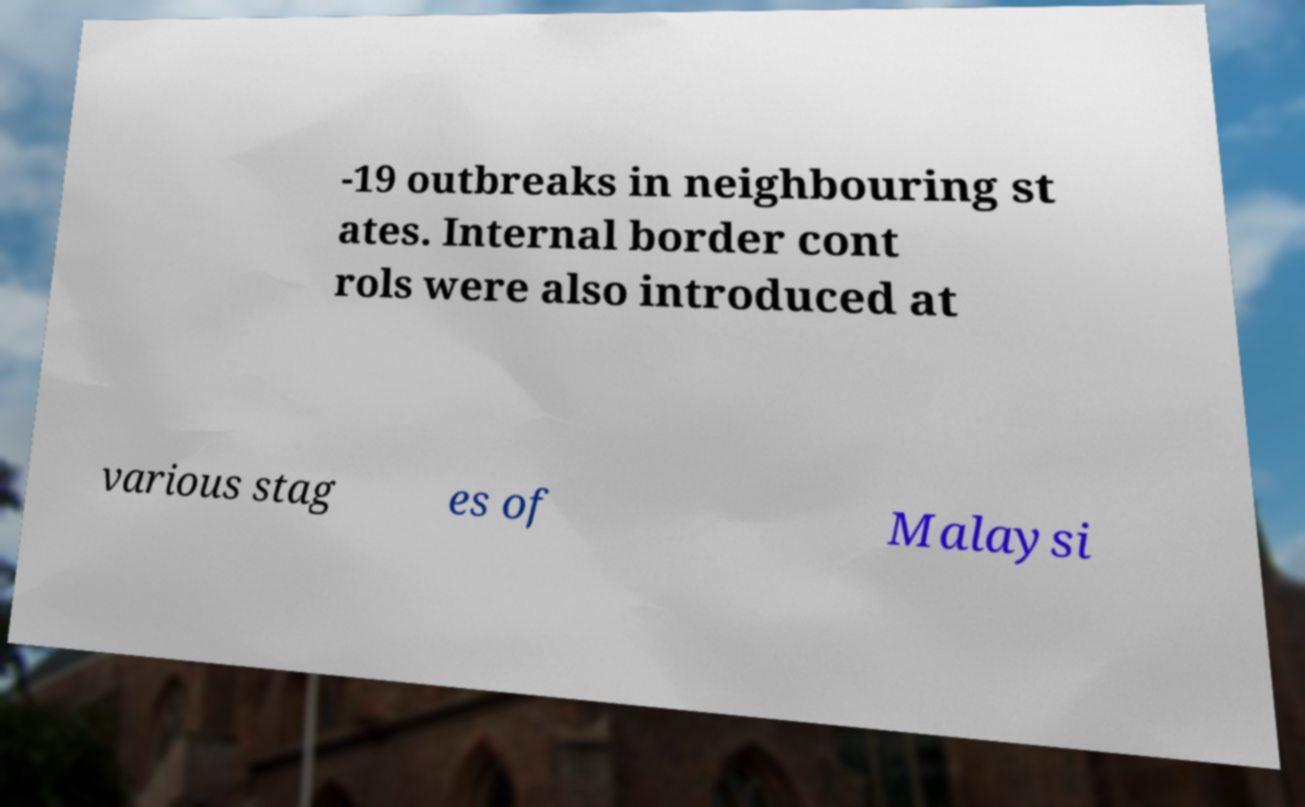Please identify and transcribe the text found in this image. -19 outbreaks in neighbouring st ates. Internal border cont rols were also introduced at various stag es of Malaysi 